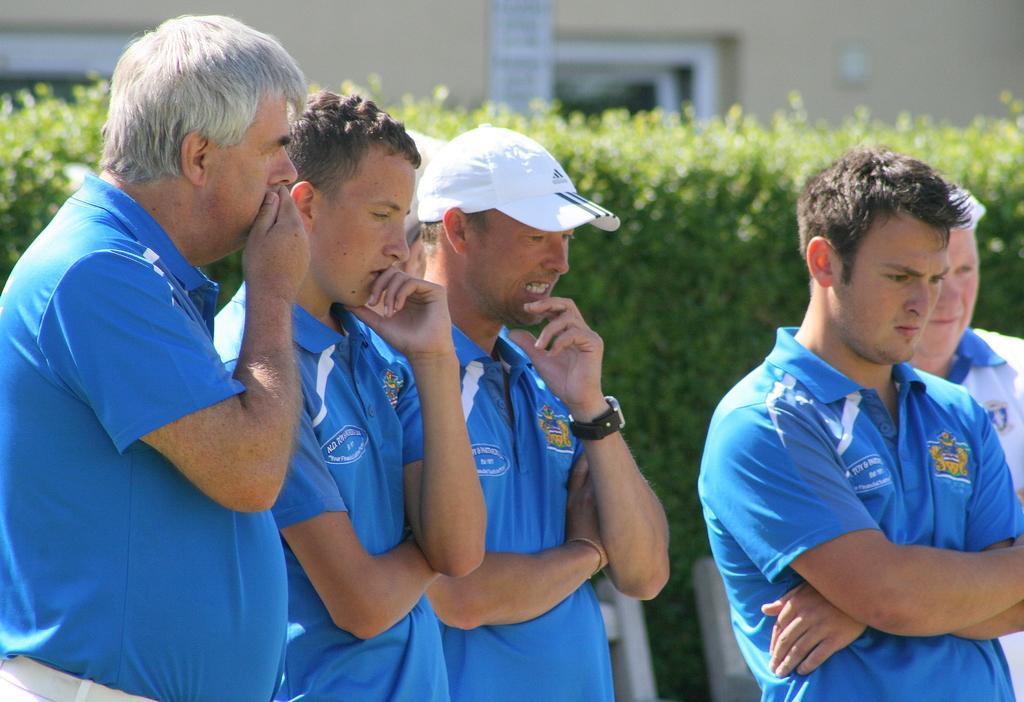How would you summarize this image in a sentence or two? In this picture there are group of people standing. At the back there is a building and there are plants and chairs. 